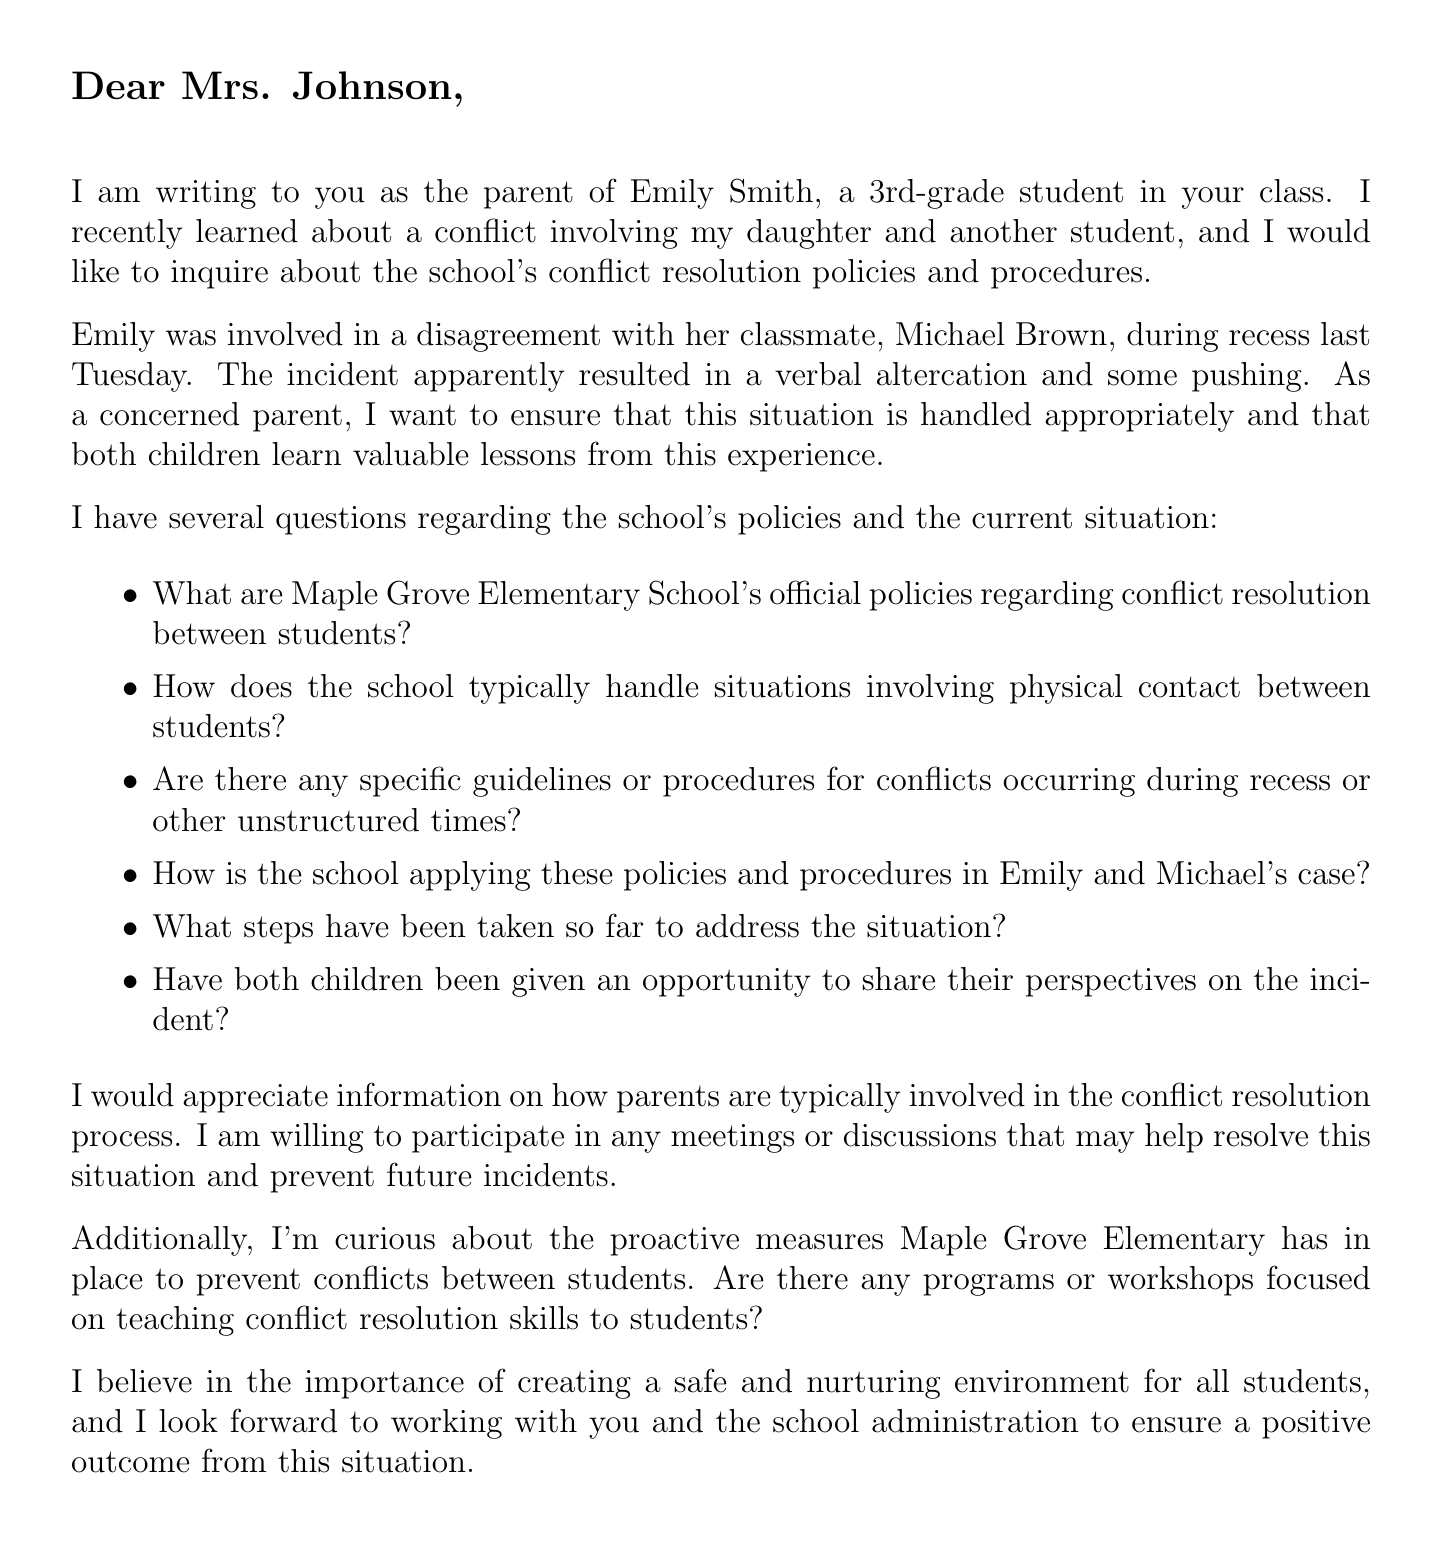What is the name of the school? The name of the school is mentioned at the beginning of the letter.
Answer: Maple Grove Elementary School Who is the parent of the student involved in the conflict? The letter specifies the name of the parent at the end.
Answer: Sarah Smith What is the grade of Emily Smith? The letter states the grade of Emily in the introduction paragraph.
Answer: 3rd-grade What incident occurred during recess? The document describes the nature of the incident involving the children during recess.
Answer: A verbal altercation and some pushing Who is the principal of Maple Grove Elementary School? The principal's name is provided under school details in the document.
Answer: Dr. Robert Thompson What conflict resolution approach does the school utilize? The document lists relevant policies concerning conflict resolution.
Answer: Restorative Justice Approach What is offered by the parent to help resolve the situation? The letter states what the parent is willing to do in the conflict resolution process.
Answer: Participate in meetings or discussions How does the letter conclude? The closing statement summarizes the author's intent and belief regarding the school environment.
Answer: I look forward to working with you and the school administration to ensure a positive outcome from this situation 